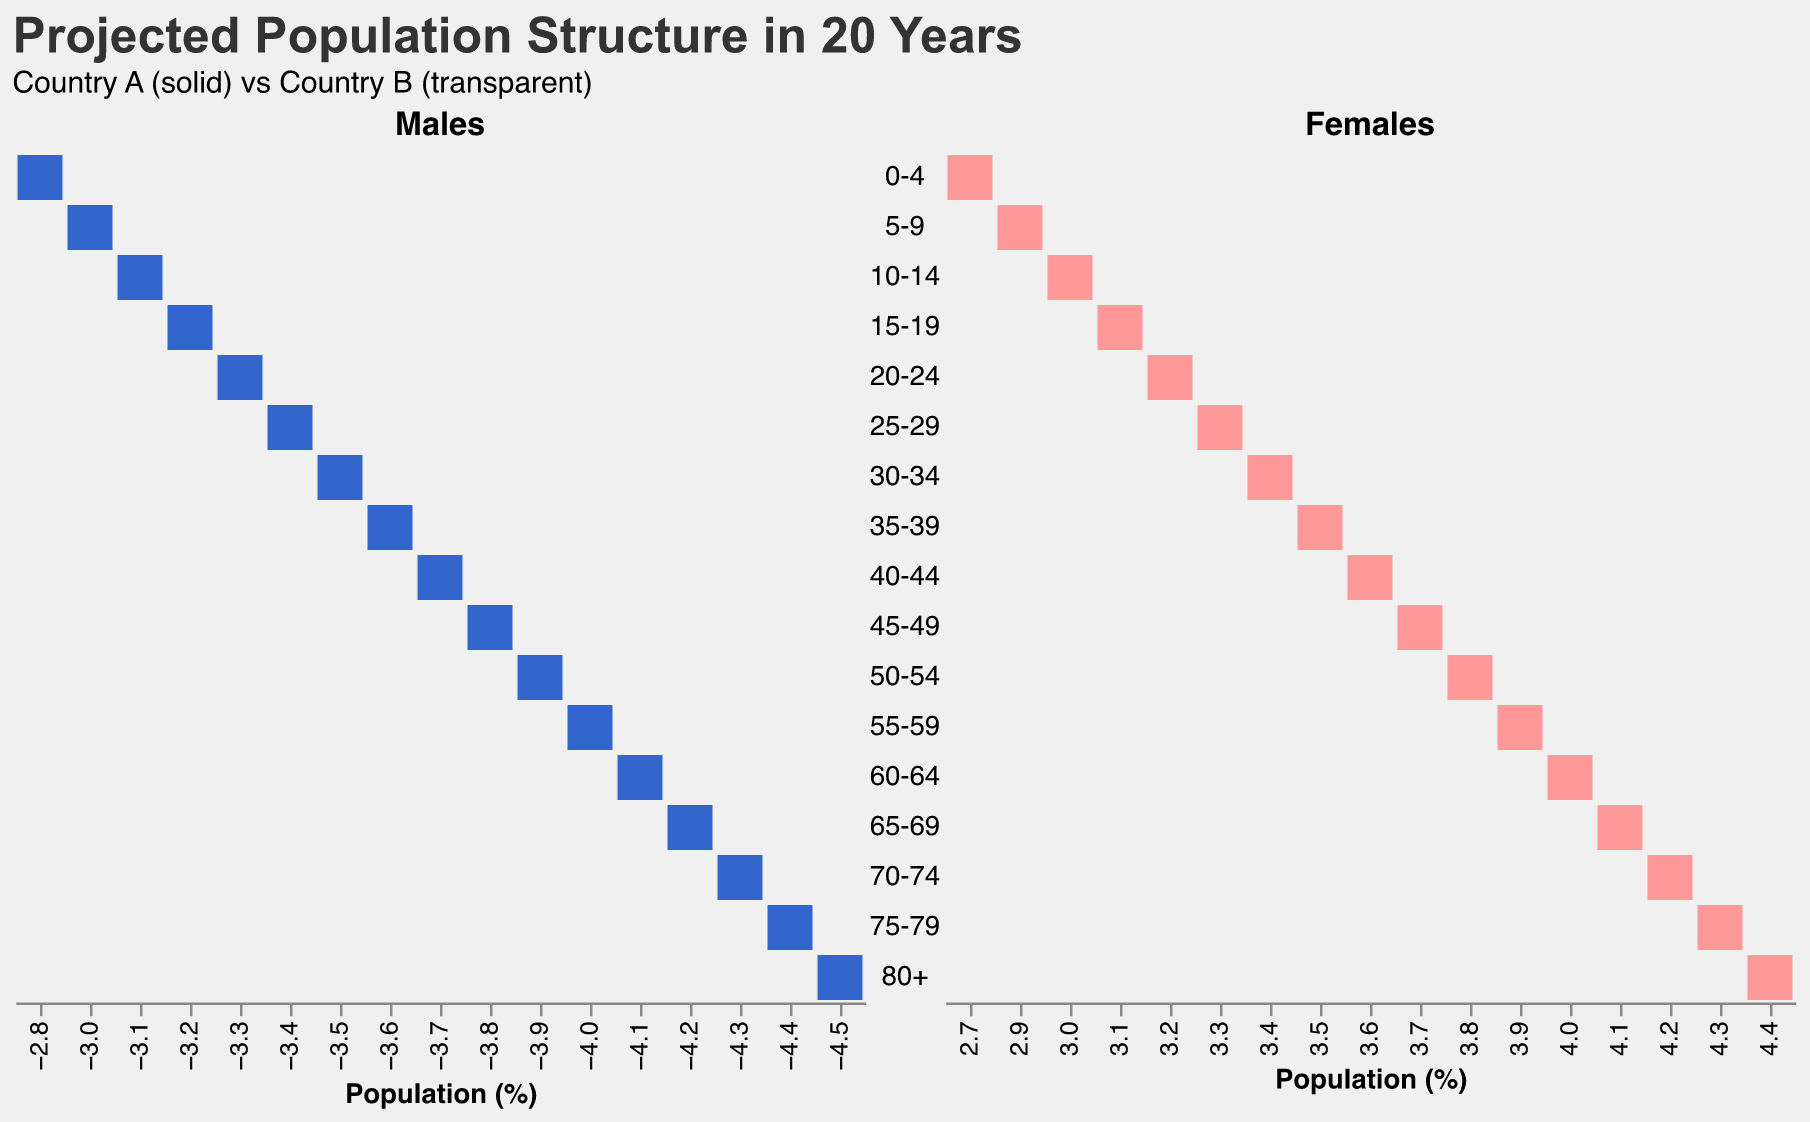How is the population pyramid structured for the youngest age group in both countries? The youngest age group is "0-4". According to the figure, Country A has 2.8% males and 2.7% females in this group, while Country B has 1.5% males and 1.4% females.
Answer: Country A: 2.8% males, 2.7% females; Country B: 1.5% males, 1.4% females Which age group has the highest male population in Country B? By observing the x-axis values associated with the bars on the population pyramid for Country B males, the age group "80+" has the highest value of 3.1%.
Answer: 80+ How does the population of females aged 30-34 compare between Country A and Country B? For females aged 30-34, Country A has 3.4%, while Country B has 2.0%. Country A has a higher percentage in this age group.
Answer: Country A: 3.4%, Country B: 2.0% What is the overall trend of the male population from age group 60-64 to 80+ in both countries? From age group 60-64 to 80+, the male population percentage increases in both countries. In Country A, it goes from 4.1% to 4.5%, and in Country B, it goes from 2.7% to 3.1%.
Answer: Increasing trend Comparing both countries, which has a higher combined population percentage for the age group 15-19? For the age group 15-19, Country A has a combined male and female population of 3.2% + 3.1% = 6.3%. Country B has 1.8% + 1.7% = 3.5%. Country A has a higher combined population percentage.
Answer: Country A: 6.3%, Country B: 3.5% What percentage difference can be seen between the male population of Country A and Country B in the age group 45-49? In the age group 45-49, the male population in Country A is 3.8%, while in Country B it is 2.4%. The difference is 3.8% - 2.4% = 1.4%.
Answer: 1.4% What is the gender ratio (males to females) for the age group 65-69 in Country A? In Country A, the age group 65-69 has 4.2% males and 4.1% females. The ratio is 4.2% / 4.1%.
Answer: 1.02:1 Which age group has the least disparity in the male population between Country A and Country B? The age group with the least disparity is found by visually comparing the bars. The "0-4" age group has the smallest difference, with Country A at 2.8% and Country B at 1.5%, a disparity of 1.3%.
Answer: 0-4 Is there any age group where the female population percentage in Country B exceeds that in Country A? By examining the figure, we can see that in every age group, the female population percentage in Country B is lower than or equal to that in Country A. Thus, no age group exceeds Country A.
Answer: No What is the total female population percentage from 70-74 to 80+ in Country A? Summing up the female population percentages for 70-74 (4.2%), 75-79 (4.3%), and 80+ (4.4%) gives 4.2% + 4.3% + 4.4% = 12.9%.
Answer: 12.9% 